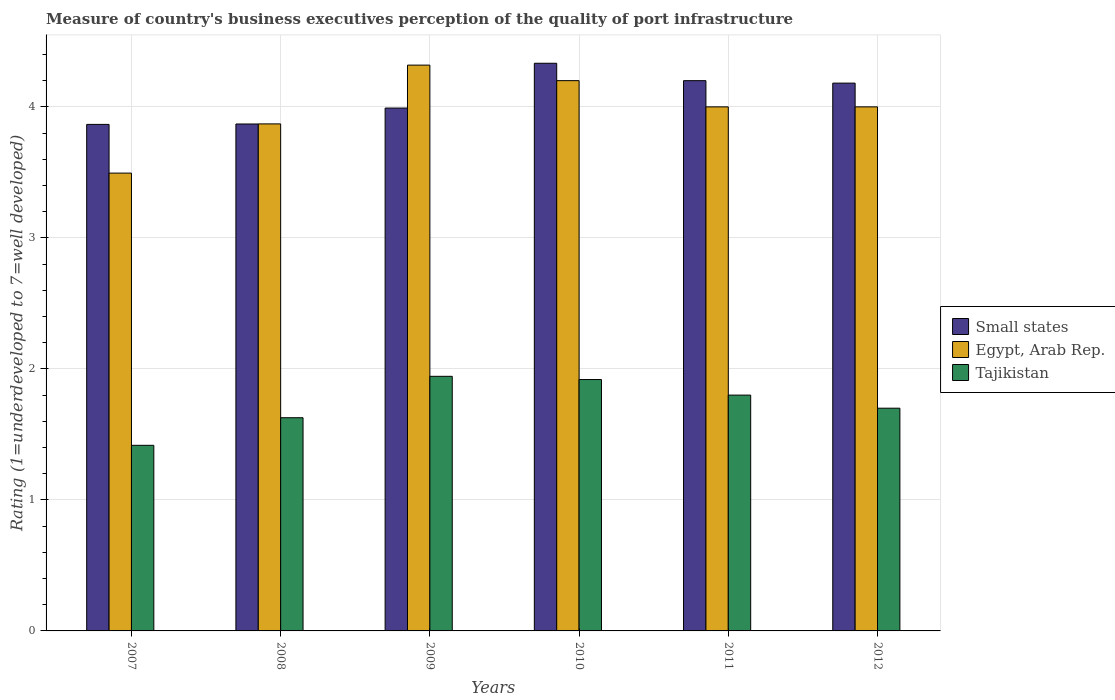How many different coloured bars are there?
Keep it short and to the point. 3. Are the number of bars per tick equal to the number of legend labels?
Give a very brief answer. Yes. How many bars are there on the 3rd tick from the left?
Your answer should be compact. 3. How many bars are there on the 6th tick from the right?
Your answer should be compact. 3. In how many cases, is the number of bars for a given year not equal to the number of legend labels?
Your answer should be very brief. 0. Across all years, what is the maximum ratings of the quality of port infrastructure in Egypt, Arab Rep.?
Ensure brevity in your answer.  4.32. Across all years, what is the minimum ratings of the quality of port infrastructure in Egypt, Arab Rep.?
Your answer should be very brief. 3.49. In which year was the ratings of the quality of port infrastructure in Small states minimum?
Your response must be concise. 2007. What is the total ratings of the quality of port infrastructure in Small states in the graph?
Give a very brief answer. 24.44. What is the difference between the ratings of the quality of port infrastructure in Tajikistan in 2009 and that in 2010?
Provide a short and direct response. 0.02. What is the difference between the ratings of the quality of port infrastructure in Tajikistan in 2007 and the ratings of the quality of port infrastructure in Egypt, Arab Rep. in 2011?
Your answer should be very brief. -2.58. What is the average ratings of the quality of port infrastructure in Tajikistan per year?
Offer a terse response. 1.73. In the year 2011, what is the difference between the ratings of the quality of port infrastructure in Small states and ratings of the quality of port infrastructure in Tajikistan?
Keep it short and to the point. 2.4. What is the ratio of the ratings of the quality of port infrastructure in Tajikistan in 2010 to that in 2012?
Ensure brevity in your answer.  1.13. Is the difference between the ratings of the quality of port infrastructure in Small states in 2009 and 2010 greater than the difference between the ratings of the quality of port infrastructure in Tajikistan in 2009 and 2010?
Offer a very short reply. No. What is the difference between the highest and the second highest ratings of the quality of port infrastructure in Tajikistan?
Your answer should be very brief. 0.02. What is the difference between the highest and the lowest ratings of the quality of port infrastructure in Egypt, Arab Rep.?
Your answer should be very brief. 0.82. Is the sum of the ratings of the quality of port infrastructure in Egypt, Arab Rep. in 2007 and 2011 greater than the maximum ratings of the quality of port infrastructure in Tajikistan across all years?
Make the answer very short. Yes. What does the 2nd bar from the left in 2012 represents?
Offer a very short reply. Egypt, Arab Rep. What does the 1st bar from the right in 2007 represents?
Keep it short and to the point. Tajikistan. How many bars are there?
Give a very brief answer. 18. Are all the bars in the graph horizontal?
Give a very brief answer. No. What is the difference between two consecutive major ticks on the Y-axis?
Offer a terse response. 1. Are the values on the major ticks of Y-axis written in scientific E-notation?
Keep it short and to the point. No. Where does the legend appear in the graph?
Make the answer very short. Center right. How many legend labels are there?
Offer a terse response. 3. How are the legend labels stacked?
Your answer should be very brief. Vertical. What is the title of the graph?
Give a very brief answer. Measure of country's business executives perception of the quality of port infrastructure. Does "Equatorial Guinea" appear as one of the legend labels in the graph?
Make the answer very short. No. What is the label or title of the X-axis?
Make the answer very short. Years. What is the label or title of the Y-axis?
Ensure brevity in your answer.  Rating (1=underdeveloped to 7=well developed). What is the Rating (1=underdeveloped to 7=well developed) of Small states in 2007?
Your response must be concise. 3.87. What is the Rating (1=underdeveloped to 7=well developed) of Egypt, Arab Rep. in 2007?
Offer a terse response. 3.49. What is the Rating (1=underdeveloped to 7=well developed) in Tajikistan in 2007?
Provide a succinct answer. 1.42. What is the Rating (1=underdeveloped to 7=well developed) of Small states in 2008?
Give a very brief answer. 3.87. What is the Rating (1=underdeveloped to 7=well developed) in Egypt, Arab Rep. in 2008?
Keep it short and to the point. 3.87. What is the Rating (1=underdeveloped to 7=well developed) of Tajikistan in 2008?
Offer a terse response. 1.63. What is the Rating (1=underdeveloped to 7=well developed) in Small states in 2009?
Your response must be concise. 3.99. What is the Rating (1=underdeveloped to 7=well developed) of Egypt, Arab Rep. in 2009?
Make the answer very short. 4.32. What is the Rating (1=underdeveloped to 7=well developed) in Tajikistan in 2009?
Your answer should be very brief. 1.94. What is the Rating (1=underdeveloped to 7=well developed) of Small states in 2010?
Your response must be concise. 4.33. What is the Rating (1=underdeveloped to 7=well developed) in Egypt, Arab Rep. in 2010?
Provide a succinct answer. 4.2. What is the Rating (1=underdeveloped to 7=well developed) of Tajikistan in 2010?
Offer a terse response. 1.92. What is the Rating (1=underdeveloped to 7=well developed) of Small states in 2011?
Your answer should be compact. 4.2. What is the Rating (1=underdeveloped to 7=well developed) of Small states in 2012?
Provide a short and direct response. 4.18. What is the Rating (1=underdeveloped to 7=well developed) of Egypt, Arab Rep. in 2012?
Your response must be concise. 4. What is the Rating (1=underdeveloped to 7=well developed) of Tajikistan in 2012?
Ensure brevity in your answer.  1.7. Across all years, what is the maximum Rating (1=underdeveloped to 7=well developed) in Small states?
Ensure brevity in your answer.  4.33. Across all years, what is the maximum Rating (1=underdeveloped to 7=well developed) of Egypt, Arab Rep.?
Offer a very short reply. 4.32. Across all years, what is the maximum Rating (1=underdeveloped to 7=well developed) of Tajikistan?
Your answer should be compact. 1.94. Across all years, what is the minimum Rating (1=underdeveloped to 7=well developed) in Small states?
Your response must be concise. 3.87. Across all years, what is the minimum Rating (1=underdeveloped to 7=well developed) of Egypt, Arab Rep.?
Offer a terse response. 3.49. Across all years, what is the minimum Rating (1=underdeveloped to 7=well developed) of Tajikistan?
Provide a succinct answer. 1.42. What is the total Rating (1=underdeveloped to 7=well developed) in Small states in the graph?
Provide a short and direct response. 24.44. What is the total Rating (1=underdeveloped to 7=well developed) in Egypt, Arab Rep. in the graph?
Your answer should be compact. 23.88. What is the total Rating (1=underdeveloped to 7=well developed) in Tajikistan in the graph?
Ensure brevity in your answer.  10.41. What is the difference between the Rating (1=underdeveloped to 7=well developed) in Small states in 2007 and that in 2008?
Give a very brief answer. -0. What is the difference between the Rating (1=underdeveloped to 7=well developed) of Egypt, Arab Rep. in 2007 and that in 2008?
Make the answer very short. -0.38. What is the difference between the Rating (1=underdeveloped to 7=well developed) in Tajikistan in 2007 and that in 2008?
Your answer should be compact. -0.21. What is the difference between the Rating (1=underdeveloped to 7=well developed) of Small states in 2007 and that in 2009?
Ensure brevity in your answer.  -0.12. What is the difference between the Rating (1=underdeveloped to 7=well developed) in Egypt, Arab Rep. in 2007 and that in 2009?
Give a very brief answer. -0.82. What is the difference between the Rating (1=underdeveloped to 7=well developed) of Tajikistan in 2007 and that in 2009?
Your answer should be very brief. -0.53. What is the difference between the Rating (1=underdeveloped to 7=well developed) of Small states in 2007 and that in 2010?
Offer a very short reply. -0.47. What is the difference between the Rating (1=underdeveloped to 7=well developed) of Egypt, Arab Rep. in 2007 and that in 2010?
Your response must be concise. -0.71. What is the difference between the Rating (1=underdeveloped to 7=well developed) in Tajikistan in 2007 and that in 2010?
Offer a very short reply. -0.5. What is the difference between the Rating (1=underdeveloped to 7=well developed) in Small states in 2007 and that in 2011?
Your answer should be very brief. -0.33. What is the difference between the Rating (1=underdeveloped to 7=well developed) in Egypt, Arab Rep. in 2007 and that in 2011?
Give a very brief answer. -0.51. What is the difference between the Rating (1=underdeveloped to 7=well developed) of Tajikistan in 2007 and that in 2011?
Offer a terse response. -0.38. What is the difference between the Rating (1=underdeveloped to 7=well developed) in Small states in 2007 and that in 2012?
Provide a short and direct response. -0.32. What is the difference between the Rating (1=underdeveloped to 7=well developed) of Egypt, Arab Rep. in 2007 and that in 2012?
Offer a very short reply. -0.51. What is the difference between the Rating (1=underdeveloped to 7=well developed) in Tajikistan in 2007 and that in 2012?
Give a very brief answer. -0.28. What is the difference between the Rating (1=underdeveloped to 7=well developed) in Small states in 2008 and that in 2009?
Offer a very short reply. -0.12. What is the difference between the Rating (1=underdeveloped to 7=well developed) in Egypt, Arab Rep. in 2008 and that in 2009?
Make the answer very short. -0.45. What is the difference between the Rating (1=underdeveloped to 7=well developed) of Tajikistan in 2008 and that in 2009?
Make the answer very short. -0.32. What is the difference between the Rating (1=underdeveloped to 7=well developed) in Small states in 2008 and that in 2010?
Ensure brevity in your answer.  -0.46. What is the difference between the Rating (1=underdeveloped to 7=well developed) in Egypt, Arab Rep. in 2008 and that in 2010?
Your answer should be very brief. -0.33. What is the difference between the Rating (1=underdeveloped to 7=well developed) in Tajikistan in 2008 and that in 2010?
Provide a short and direct response. -0.29. What is the difference between the Rating (1=underdeveloped to 7=well developed) in Small states in 2008 and that in 2011?
Your response must be concise. -0.33. What is the difference between the Rating (1=underdeveloped to 7=well developed) of Egypt, Arab Rep. in 2008 and that in 2011?
Provide a short and direct response. -0.13. What is the difference between the Rating (1=underdeveloped to 7=well developed) in Tajikistan in 2008 and that in 2011?
Your response must be concise. -0.17. What is the difference between the Rating (1=underdeveloped to 7=well developed) of Small states in 2008 and that in 2012?
Offer a terse response. -0.31. What is the difference between the Rating (1=underdeveloped to 7=well developed) in Egypt, Arab Rep. in 2008 and that in 2012?
Ensure brevity in your answer.  -0.13. What is the difference between the Rating (1=underdeveloped to 7=well developed) of Tajikistan in 2008 and that in 2012?
Offer a terse response. -0.07. What is the difference between the Rating (1=underdeveloped to 7=well developed) in Small states in 2009 and that in 2010?
Offer a terse response. -0.34. What is the difference between the Rating (1=underdeveloped to 7=well developed) of Egypt, Arab Rep. in 2009 and that in 2010?
Provide a short and direct response. 0.12. What is the difference between the Rating (1=underdeveloped to 7=well developed) of Tajikistan in 2009 and that in 2010?
Your response must be concise. 0.02. What is the difference between the Rating (1=underdeveloped to 7=well developed) in Small states in 2009 and that in 2011?
Provide a short and direct response. -0.21. What is the difference between the Rating (1=underdeveloped to 7=well developed) in Egypt, Arab Rep. in 2009 and that in 2011?
Give a very brief answer. 0.32. What is the difference between the Rating (1=underdeveloped to 7=well developed) in Tajikistan in 2009 and that in 2011?
Offer a terse response. 0.14. What is the difference between the Rating (1=underdeveloped to 7=well developed) in Small states in 2009 and that in 2012?
Make the answer very short. -0.19. What is the difference between the Rating (1=underdeveloped to 7=well developed) of Egypt, Arab Rep. in 2009 and that in 2012?
Offer a very short reply. 0.32. What is the difference between the Rating (1=underdeveloped to 7=well developed) in Tajikistan in 2009 and that in 2012?
Your answer should be compact. 0.24. What is the difference between the Rating (1=underdeveloped to 7=well developed) of Small states in 2010 and that in 2011?
Your response must be concise. 0.13. What is the difference between the Rating (1=underdeveloped to 7=well developed) in Egypt, Arab Rep. in 2010 and that in 2011?
Offer a very short reply. 0.2. What is the difference between the Rating (1=underdeveloped to 7=well developed) of Tajikistan in 2010 and that in 2011?
Make the answer very short. 0.12. What is the difference between the Rating (1=underdeveloped to 7=well developed) in Small states in 2010 and that in 2012?
Give a very brief answer. 0.15. What is the difference between the Rating (1=underdeveloped to 7=well developed) of Egypt, Arab Rep. in 2010 and that in 2012?
Offer a very short reply. 0.2. What is the difference between the Rating (1=underdeveloped to 7=well developed) of Tajikistan in 2010 and that in 2012?
Make the answer very short. 0.22. What is the difference between the Rating (1=underdeveloped to 7=well developed) of Small states in 2011 and that in 2012?
Ensure brevity in your answer.  0.02. What is the difference between the Rating (1=underdeveloped to 7=well developed) in Egypt, Arab Rep. in 2011 and that in 2012?
Make the answer very short. 0. What is the difference between the Rating (1=underdeveloped to 7=well developed) in Small states in 2007 and the Rating (1=underdeveloped to 7=well developed) in Egypt, Arab Rep. in 2008?
Your response must be concise. -0. What is the difference between the Rating (1=underdeveloped to 7=well developed) in Small states in 2007 and the Rating (1=underdeveloped to 7=well developed) in Tajikistan in 2008?
Offer a terse response. 2.24. What is the difference between the Rating (1=underdeveloped to 7=well developed) of Egypt, Arab Rep. in 2007 and the Rating (1=underdeveloped to 7=well developed) of Tajikistan in 2008?
Provide a succinct answer. 1.87. What is the difference between the Rating (1=underdeveloped to 7=well developed) in Small states in 2007 and the Rating (1=underdeveloped to 7=well developed) in Egypt, Arab Rep. in 2009?
Offer a very short reply. -0.45. What is the difference between the Rating (1=underdeveloped to 7=well developed) of Small states in 2007 and the Rating (1=underdeveloped to 7=well developed) of Tajikistan in 2009?
Make the answer very short. 1.92. What is the difference between the Rating (1=underdeveloped to 7=well developed) of Egypt, Arab Rep. in 2007 and the Rating (1=underdeveloped to 7=well developed) of Tajikistan in 2009?
Your answer should be compact. 1.55. What is the difference between the Rating (1=underdeveloped to 7=well developed) of Small states in 2007 and the Rating (1=underdeveloped to 7=well developed) of Egypt, Arab Rep. in 2010?
Keep it short and to the point. -0.33. What is the difference between the Rating (1=underdeveloped to 7=well developed) of Small states in 2007 and the Rating (1=underdeveloped to 7=well developed) of Tajikistan in 2010?
Make the answer very short. 1.95. What is the difference between the Rating (1=underdeveloped to 7=well developed) of Egypt, Arab Rep. in 2007 and the Rating (1=underdeveloped to 7=well developed) of Tajikistan in 2010?
Make the answer very short. 1.58. What is the difference between the Rating (1=underdeveloped to 7=well developed) in Small states in 2007 and the Rating (1=underdeveloped to 7=well developed) in Egypt, Arab Rep. in 2011?
Give a very brief answer. -0.13. What is the difference between the Rating (1=underdeveloped to 7=well developed) in Small states in 2007 and the Rating (1=underdeveloped to 7=well developed) in Tajikistan in 2011?
Your response must be concise. 2.07. What is the difference between the Rating (1=underdeveloped to 7=well developed) in Egypt, Arab Rep. in 2007 and the Rating (1=underdeveloped to 7=well developed) in Tajikistan in 2011?
Your answer should be very brief. 1.69. What is the difference between the Rating (1=underdeveloped to 7=well developed) in Small states in 2007 and the Rating (1=underdeveloped to 7=well developed) in Egypt, Arab Rep. in 2012?
Make the answer very short. -0.13. What is the difference between the Rating (1=underdeveloped to 7=well developed) in Small states in 2007 and the Rating (1=underdeveloped to 7=well developed) in Tajikistan in 2012?
Your answer should be very brief. 2.17. What is the difference between the Rating (1=underdeveloped to 7=well developed) in Egypt, Arab Rep. in 2007 and the Rating (1=underdeveloped to 7=well developed) in Tajikistan in 2012?
Give a very brief answer. 1.79. What is the difference between the Rating (1=underdeveloped to 7=well developed) of Small states in 2008 and the Rating (1=underdeveloped to 7=well developed) of Egypt, Arab Rep. in 2009?
Your answer should be compact. -0.45. What is the difference between the Rating (1=underdeveloped to 7=well developed) in Small states in 2008 and the Rating (1=underdeveloped to 7=well developed) in Tajikistan in 2009?
Offer a terse response. 1.93. What is the difference between the Rating (1=underdeveloped to 7=well developed) in Egypt, Arab Rep. in 2008 and the Rating (1=underdeveloped to 7=well developed) in Tajikistan in 2009?
Provide a short and direct response. 1.93. What is the difference between the Rating (1=underdeveloped to 7=well developed) of Small states in 2008 and the Rating (1=underdeveloped to 7=well developed) of Egypt, Arab Rep. in 2010?
Provide a short and direct response. -0.33. What is the difference between the Rating (1=underdeveloped to 7=well developed) of Small states in 2008 and the Rating (1=underdeveloped to 7=well developed) of Tajikistan in 2010?
Ensure brevity in your answer.  1.95. What is the difference between the Rating (1=underdeveloped to 7=well developed) in Egypt, Arab Rep. in 2008 and the Rating (1=underdeveloped to 7=well developed) in Tajikistan in 2010?
Give a very brief answer. 1.95. What is the difference between the Rating (1=underdeveloped to 7=well developed) in Small states in 2008 and the Rating (1=underdeveloped to 7=well developed) in Egypt, Arab Rep. in 2011?
Ensure brevity in your answer.  -0.13. What is the difference between the Rating (1=underdeveloped to 7=well developed) in Small states in 2008 and the Rating (1=underdeveloped to 7=well developed) in Tajikistan in 2011?
Your answer should be very brief. 2.07. What is the difference between the Rating (1=underdeveloped to 7=well developed) in Egypt, Arab Rep. in 2008 and the Rating (1=underdeveloped to 7=well developed) in Tajikistan in 2011?
Offer a very short reply. 2.07. What is the difference between the Rating (1=underdeveloped to 7=well developed) of Small states in 2008 and the Rating (1=underdeveloped to 7=well developed) of Egypt, Arab Rep. in 2012?
Your response must be concise. -0.13. What is the difference between the Rating (1=underdeveloped to 7=well developed) in Small states in 2008 and the Rating (1=underdeveloped to 7=well developed) in Tajikistan in 2012?
Ensure brevity in your answer.  2.17. What is the difference between the Rating (1=underdeveloped to 7=well developed) in Egypt, Arab Rep. in 2008 and the Rating (1=underdeveloped to 7=well developed) in Tajikistan in 2012?
Your answer should be very brief. 2.17. What is the difference between the Rating (1=underdeveloped to 7=well developed) of Small states in 2009 and the Rating (1=underdeveloped to 7=well developed) of Egypt, Arab Rep. in 2010?
Ensure brevity in your answer.  -0.21. What is the difference between the Rating (1=underdeveloped to 7=well developed) of Small states in 2009 and the Rating (1=underdeveloped to 7=well developed) of Tajikistan in 2010?
Give a very brief answer. 2.07. What is the difference between the Rating (1=underdeveloped to 7=well developed) in Egypt, Arab Rep. in 2009 and the Rating (1=underdeveloped to 7=well developed) in Tajikistan in 2010?
Keep it short and to the point. 2.4. What is the difference between the Rating (1=underdeveloped to 7=well developed) in Small states in 2009 and the Rating (1=underdeveloped to 7=well developed) in Egypt, Arab Rep. in 2011?
Your answer should be very brief. -0.01. What is the difference between the Rating (1=underdeveloped to 7=well developed) of Small states in 2009 and the Rating (1=underdeveloped to 7=well developed) of Tajikistan in 2011?
Give a very brief answer. 2.19. What is the difference between the Rating (1=underdeveloped to 7=well developed) in Egypt, Arab Rep. in 2009 and the Rating (1=underdeveloped to 7=well developed) in Tajikistan in 2011?
Offer a terse response. 2.52. What is the difference between the Rating (1=underdeveloped to 7=well developed) in Small states in 2009 and the Rating (1=underdeveloped to 7=well developed) in Egypt, Arab Rep. in 2012?
Keep it short and to the point. -0.01. What is the difference between the Rating (1=underdeveloped to 7=well developed) of Small states in 2009 and the Rating (1=underdeveloped to 7=well developed) of Tajikistan in 2012?
Your response must be concise. 2.29. What is the difference between the Rating (1=underdeveloped to 7=well developed) of Egypt, Arab Rep. in 2009 and the Rating (1=underdeveloped to 7=well developed) of Tajikistan in 2012?
Provide a succinct answer. 2.62. What is the difference between the Rating (1=underdeveloped to 7=well developed) of Small states in 2010 and the Rating (1=underdeveloped to 7=well developed) of Egypt, Arab Rep. in 2011?
Give a very brief answer. 0.33. What is the difference between the Rating (1=underdeveloped to 7=well developed) of Small states in 2010 and the Rating (1=underdeveloped to 7=well developed) of Tajikistan in 2011?
Provide a succinct answer. 2.53. What is the difference between the Rating (1=underdeveloped to 7=well developed) of Egypt, Arab Rep. in 2010 and the Rating (1=underdeveloped to 7=well developed) of Tajikistan in 2011?
Offer a very short reply. 2.4. What is the difference between the Rating (1=underdeveloped to 7=well developed) in Small states in 2010 and the Rating (1=underdeveloped to 7=well developed) in Egypt, Arab Rep. in 2012?
Offer a very short reply. 0.33. What is the difference between the Rating (1=underdeveloped to 7=well developed) of Small states in 2010 and the Rating (1=underdeveloped to 7=well developed) of Tajikistan in 2012?
Ensure brevity in your answer.  2.63. What is the difference between the Rating (1=underdeveloped to 7=well developed) in Egypt, Arab Rep. in 2010 and the Rating (1=underdeveloped to 7=well developed) in Tajikistan in 2012?
Your response must be concise. 2.5. What is the average Rating (1=underdeveloped to 7=well developed) of Small states per year?
Offer a very short reply. 4.07. What is the average Rating (1=underdeveloped to 7=well developed) of Egypt, Arab Rep. per year?
Keep it short and to the point. 3.98. What is the average Rating (1=underdeveloped to 7=well developed) of Tajikistan per year?
Provide a short and direct response. 1.73. In the year 2007, what is the difference between the Rating (1=underdeveloped to 7=well developed) in Small states and Rating (1=underdeveloped to 7=well developed) in Egypt, Arab Rep.?
Offer a very short reply. 0.37. In the year 2007, what is the difference between the Rating (1=underdeveloped to 7=well developed) of Small states and Rating (1=underdeveloped to 7=well developed) of Tajikistan?
Provide a succinct answer. 2.45. In the year 2007, what is the difference between the Rating (1=underdeveloped to 7=well developed) of Egypt, Arab Rep. and Rating (1=underdeveloped to 7=well developed) of Tajikistan?
Provide a short and direct response. 2.08. In the year 2008, what is the difference between the Rating (1=underdeveloped to 7=well developed) in Small states and Rating (1=underdeveloped to 7=well developed) in Egypt, Arab Rep.?
Your response must be concise. -0. In the year 2008, what is the difference between the Rating (1=underdeveloped to 7=well developed) in Small states and Rating (1=underdeveloped to 7=well developed) in Tajikistan?
Keep it short and to the point. 2.24. In the year 2008, what is the difference between the Rating (1=underdeveloped to 7=well developed) in Egypt, Arab Rep. and Rating (1=underdeveloped to 7=well developed) in Tajikistan?
Keep it short and to the point. 2.24. In the year 2009, what is the difference between the Rating (1=underdeveloped to 7=well developed) of Small states and Rating (1=underdeveloped to 7=well developed) of Egypt, Arab Rep.?
Offer a very short reply. -0.33. In the year 2009, what is the difference between the Rating (1=underdeveloped to 7=well developed) in Small states and Rating (1=underdeveloped to 7=well developed) in Tajikistan?
Give a very brief answer. 2.05. In the year 2009, what is the difference between the Rating (1=underdeveloped to 7=well developed) of Egypt, Arab Rep. and Rating (1=underdeveloped to 7=well developed) of Tajikistan?
Make the answer very short. 2.38. In the year 2010, what is the difference between the Rating (1=underdeveloped to 7=well developed) in Small states and Rating (1=underdeveloped to 7=well developed) in Egypt, Arab Rep.?
Make the answer very short. 0.13. In the year 2010, what is the difference between the Rating (1=underdeveloped to 7=well developed) in Small states and Rating (1=underdeveloped to 7=well developed) in Tajikistan?
Give a very brief answer. 2.41. In the year 2010, what is the difference between the Rating (1=underdeveloped to 7=well developed) of Egypt, Arab Rep. and Rating (1=underdeveloped to 7=well developed) of Tajikistan?
Your answer should be very brief. 2.28. In the year 2011, what is the difference between the Rating (1=underdeveloped to 7=well developed) in Small states and Rating (1=underdeveloped to 7=well developed) in Egypt, Arab Rep.?
Your answer should be very brief. 0.2. In the year 2011, what is the difference between the Rating (1=underdeveloped to 7=well developed) of Small states and Rating (1=underdeveloped to 7=well developed) of Tajikistan?
Keep it short and to the point. 2.4. In the year 2012, what is the difference between the Rating (1=underdeveloped to 7=well developed) in Small states and Rating (1=underdeveloped to 7=well developed) in Egypt, Arab Rep.?
Your response must be concise. 0.18. In the year 2012, what is the difference between the Rating (1=underdeveloped to 7=well developed) of Small states and Rating (1=underdeveloped to 7=well developed) of Tajikistan?
Your answer should be compact. 2.48. What is the ratio of the Rating (1=underdeveloped to 7=well developed) in Small states in 2007 to that in 2008?
Provide a succinct answer. 1. What is the ratio of the Rating (1=underdeveloped to 7=well developed) in Egypt, Arab Rep. in 2007 to that in 2008?
Give a very brief answer. 0.9. What is the ratio of the Rating (1=underdeveloped to 7=well developed) in Tajikistan in 2007 to that in 2008?
Ensure brevity in your answer.  0.87. What is the ratio of the Rating (1=underdeveloped to 7=well developed) in Small states in 2007 to that in 2009?
Offer a terse response. 0.97. What is the ratio of the Rating (1=underdeveloped to 7=well developed) in Egypt, Arab Rep. in 2007 to that in 2009?
Provide a short and direct response. 0.81. What is the ratio of the Rating (1=underdeveloped to 7=well developed) of Tajikistan in 2007 to that in 2009?
Keep it short and to the point. 0.73. What is the ratio of the Rating (1=underdeveloped to 7=well developed) in Small states in 2007 to that in 2010?
Offer a very short reply. 0.89. What is the ratio of the Rating (1=underdeveloped to 7=well developed) of Egypt, Arab Rep. in 2007 to that in 2010?
Offer a very short reply. 0.83. What is the ratio of the Rating (1=underdeveloped to 7=well developed) in Tajikistan in 2007 to that in 2010?
Give a very brief answer. 0.74. What is the ratio of the Rating (1=underdeveloped to 7=well developed) of Small states in 2007 to that in 2011?
Offer a terse response. 0.92. What is the ratio of the Rating (1=underdeveloped to 7=well developed) of Egypt, Arab Rep. in 2007 to that in 2011?
Provide a short and direct response. 0.87. What is the ratio of the Rating (1=underdeveloped to 7=well developed) in Tajikistan in 2007 to that in 2011?
Your answer should be compact. 0.79. What is the ratio of the Rating (1=underdeveloped to 7=well developed) in Small states in 2007 to that in 2012?
Give a very brief answer. 0.92. What is the ratio of the Rating (1=underdeveloped to 7=well developed) of Egypt, Arab Rep. in 2007 to that in 2012?
Provide a short and direct response. 0.87. What is the ratio of the Rating (1=underdeveloped to 7=well developed) in Tajikistan in 2007 to that in 2012?
Your answer should be compact. 0.83. What is the ratio of the Rating (1=underdeveloped to 7=well developed) of Small states in 2008 to that in 2009?
Your answer should be very brief. 0.97. What is the ratio of the Rating (1=underdeveloped to 7=well developed) of Egypt, Arab Rep. in 2008 to that in 2009?
Keep it short and to the point. 0.9. What is the ratio of the Rating (1=underdeveloped to 7=well developed) in Tajikistan in 2008 to that in 2009?
Offer a very short reply. 0.84. What is the ratio of the Rating (1=underdeveloped to 7=well developed) of Small states in 2008 to that in 2010?
Keep it short and to the point. 0.89. What is the ratio of the Rating (1=underdeveloped to 7=well developed) of Egypt, Arab Rep. in 2008 to that in 2010?
Offer a very short reply. 0.92. What is the ratio of the Rating (1=underdeveloped to 7=well developed) of Tajikistan in 2008 to that in 2010?
Offer a terse response. 0.85. What is the ratio of the Rating (1=underdeveloped to 7=well developed) of Small states in 2008 to that in 2011?
Your response must be concise. 0.92. What is the ratio of the Rating (1=underdeveloped to 7=well developed) in Egypt, Arab Rep. in 2008 to that in 2011?
Keep it short and to the point. 0.97. What is the ratio of the Rating (1=underdeveloped to 7=well developed) of Tajikistan in 2008 to that in 2011?
Provide a short and direct response. 0.9. What is the ratio of the Rating (1=underdeveloped to 7=well developed) in Small states in 2008 to that in 2012?
Offer a terse response. 0.93. What is the ratio of the Rating (1=underdeveloped to 7=well developed) of Egypt, Arab Rep. in 2008 to that in 2012?
Make the answer very short. 0.97. What is the ratio of the Rating (1=underdeveloped to 7=well developed) of Tajikistan in 2008 to that in 2012?
Provide a short and direct response. 0.96. What is the ratio of the Rating (1=underdeveloped to 7=well developed) of Small states in 2009 to that in 2010?
Offer a terse response. 0.92. What is the ratio of the Rating (1=underdeveloped to 7=well developed) of Egypt, Arab Rep. in 2009 to that in 2010?
Give a very brief answer. 1.03. What is the ratio of the Rating (1=underdeveloped to 7=well developed) in Tajikistan in 2009 to that in 2010?
Your answer should be very brief. 1.01. What is the ratio of the Rating (1=underdeveloped to 7=well developed) of Small states in 2009 to that in 2011?
Your response must be concise. 0.95. What is the ratio of the Rating (1=underdeveloped to 7=well developed) of Egypt, Arab Rep. in 2009 to that in 2011?
Offer a very short reply. 1.08. What is the ratio of the Rating (1=underdeveloped to 7=well developed) of Tajikistan in 2009 to that in 2011?
Provide a succinct answer. 1.08. What is the ratio of the Rating (1=underdeveloped to 7=well developed) of Small states in 2009 to that in 2012?
Ensure brevity in your answer.  0.95. What is the ratio of the Rating (1=underdeveloped to 7=well developed) in Egypt, Arab Rep. in 2009 to that in 2012?
Your answer should be very brief. 1.08. What is the ratio of the Rating (1=underdeveloped to 7=well developed) in Tajikistan in 2009 to that in 2012?
Offer a very short reply. 1.14. What is the ratio of the Rating (1=underdeveloped to 7=well developed) in Small states in 2010 to that in 2011?
Ensure brevity in your answer.  1.03. What is the ratio of the Rating (1=underdeveloped to 7=well developed) of Tajikistan in 2010 to that in 2011?
Ensure brevity in your answer.  1.07. What is the ratio of the Rating (1=underdeveloped to 7=well developed) in Small states in 2010 to that in 2012?
Ensure brevity in your answer.  1.04. What is the ratio of the Rating (1=underdeveloped to 7=well developed) in Egypt, Arab Rep. in 2010 to that in 2012?
Your answer should be compact. 1.05. What is the ratio of the Rating (1=underdeveloped to 7=well developed) in Tajikistan in 2010 to that in 2012?
Your response must be concise. 1.13. What is the ratio of the Rating (1=underdeveloped to 7=well developed) in Small states in 2011 to that in 2012?
Keep it short and to the point. 1. What is the ratio of the Rating (1=underdeveloped to 7=well developed) in Tajikistan in 2011 to that in 2012?
Your answer should be very brief. 1.06. What is the difference between the highest and the second highest Rating (1=underdeveloped to 7=well developed) in Small states?
Ensure brevity in your answer.  0.13. What is the difference between the highest and the second highest Rating (1=underdeveloped to 7=well developed) in Egypt, Arab Rep.?
Ensure brevity in your answer.  0.12. What is the difference between the highest and the second highest Rating (1=underdeveloped to 7=well developed) in Tajikistan?
Your answer should be compact. 0.02. What is the difference between the highest and the lowest Rating (1=underdeveloped to 7=well developed) of Small states?
Ensure brevity in your answer.  0.47. What is the difference between the highest and the lowest Rating (1=underdeveloped to 7=well developed) in Egypt, Arab Rep.?
Give a very brief answer. 0.82. What is the difference between the highest and the lowest Rating (1=underdeveloped to 7=well developed) of Tajikistan?
Give a very brief answer. 0.53. 